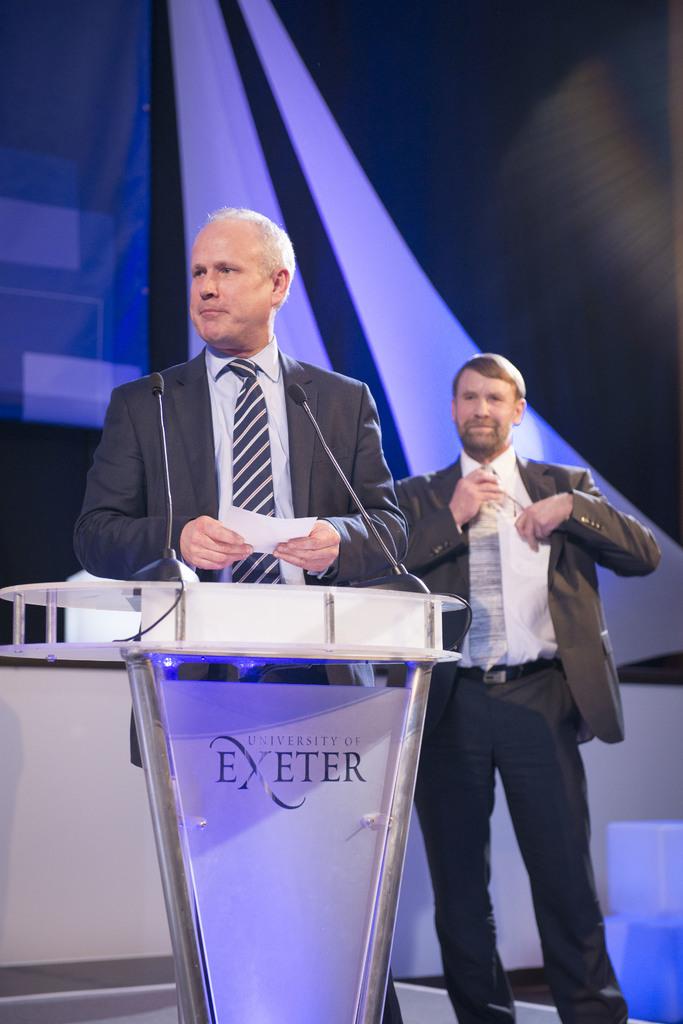What university is hosting this event?
Give a very brief answer. Exeter. 